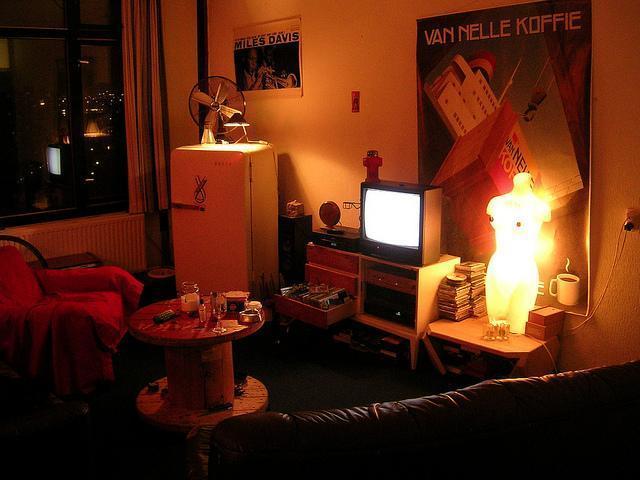How many person carry bag in their hand?
Give a very brief answer. 0. 